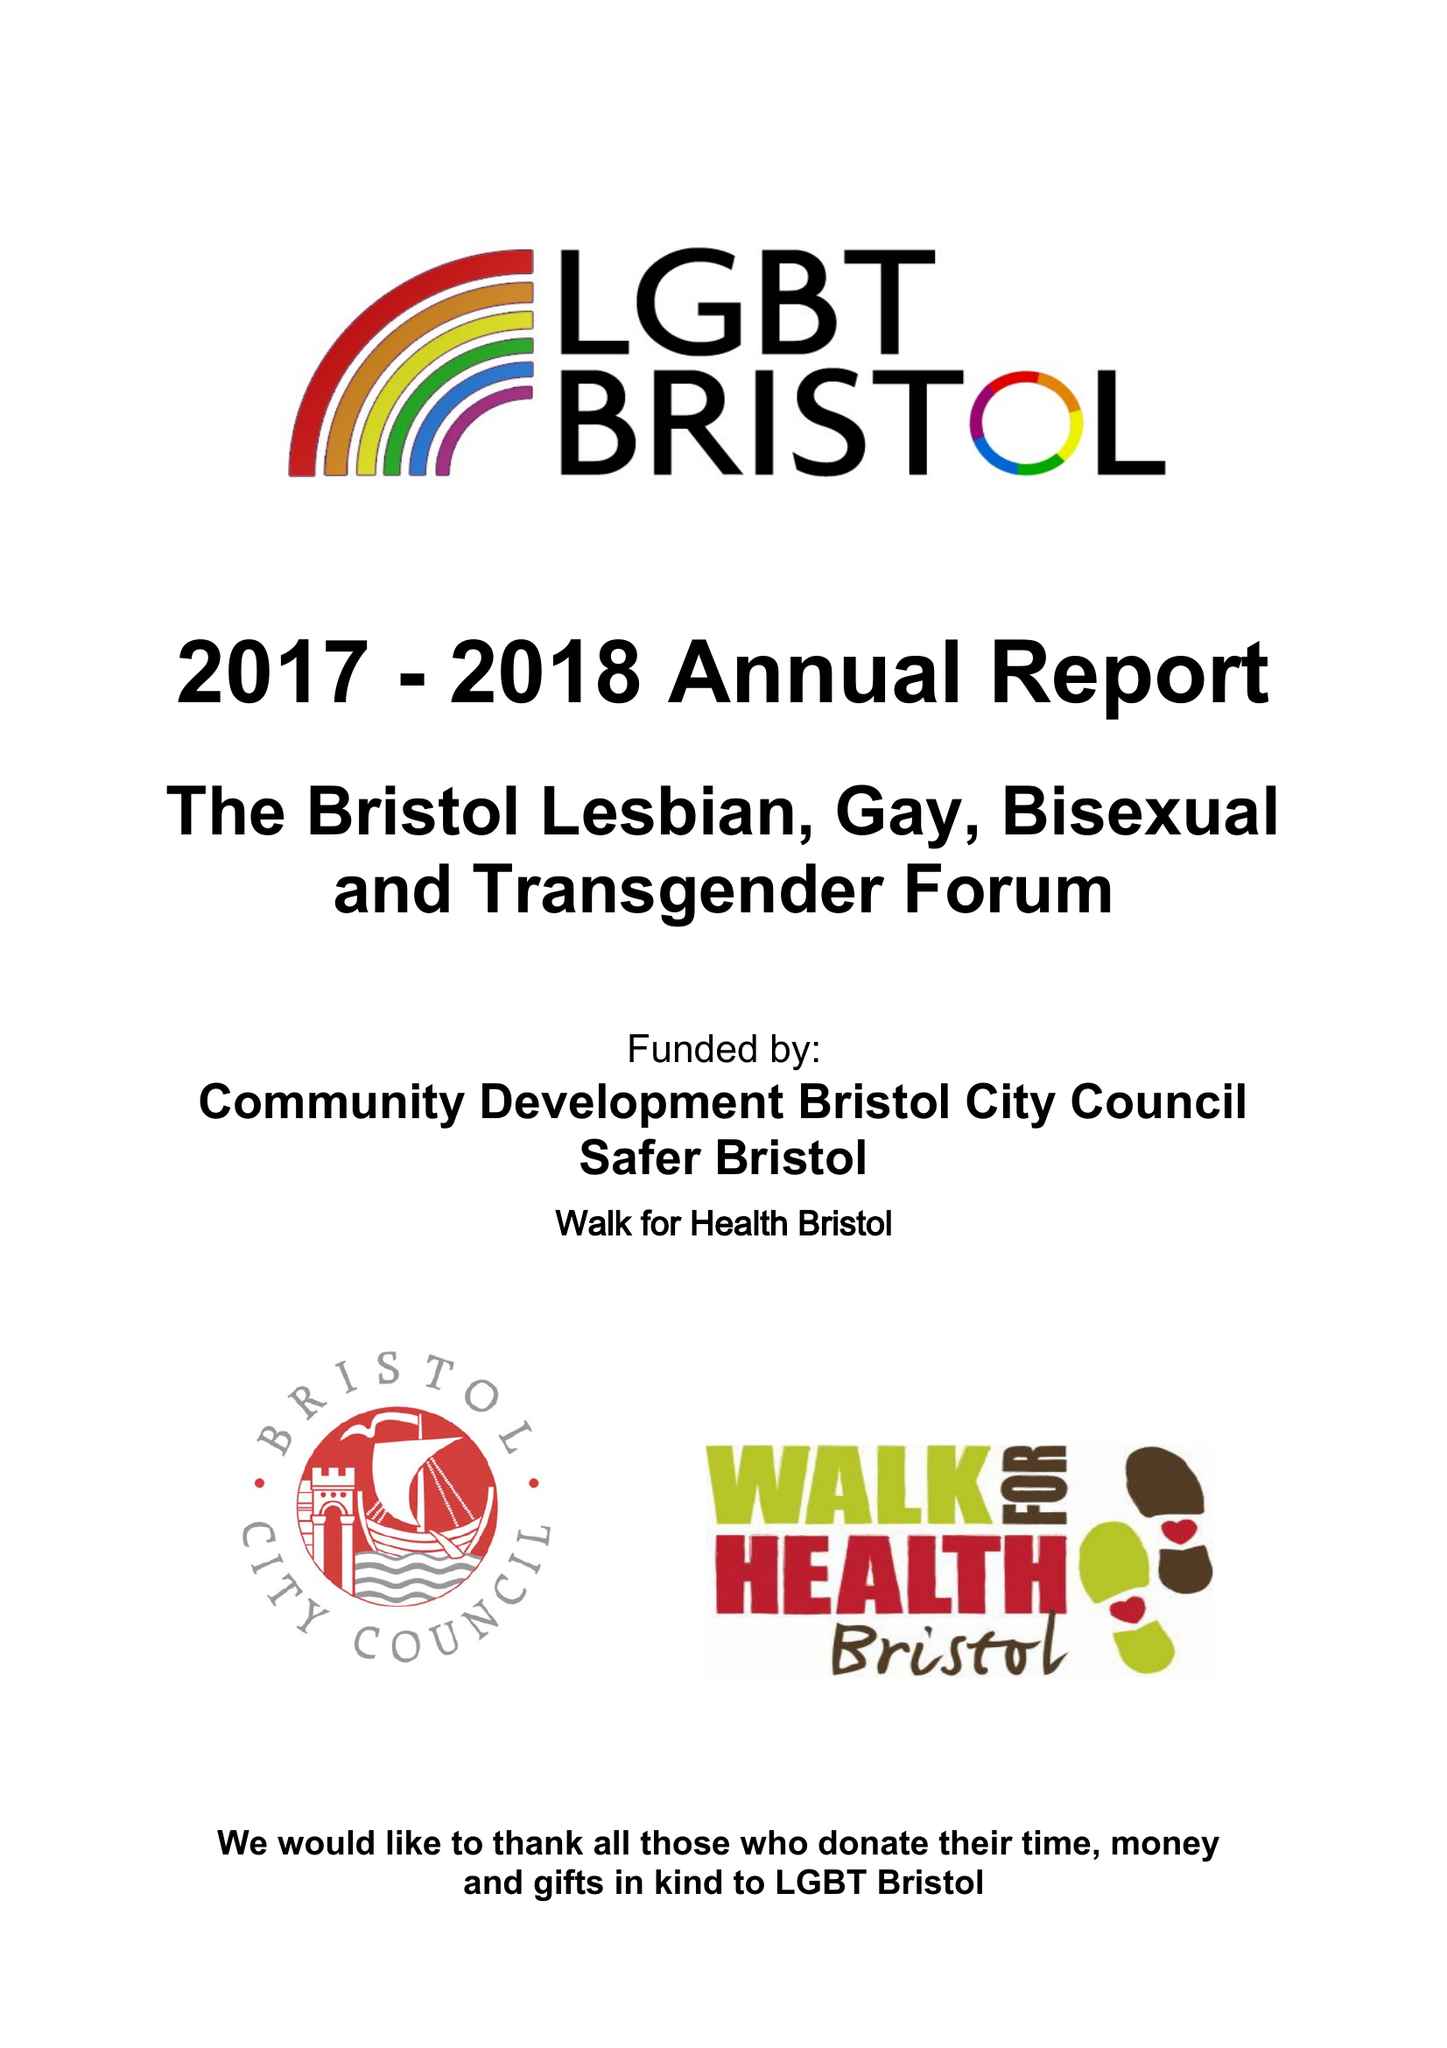What is the value for the report_date?
Answer the question using a single word or phrase. 2018-03-31 